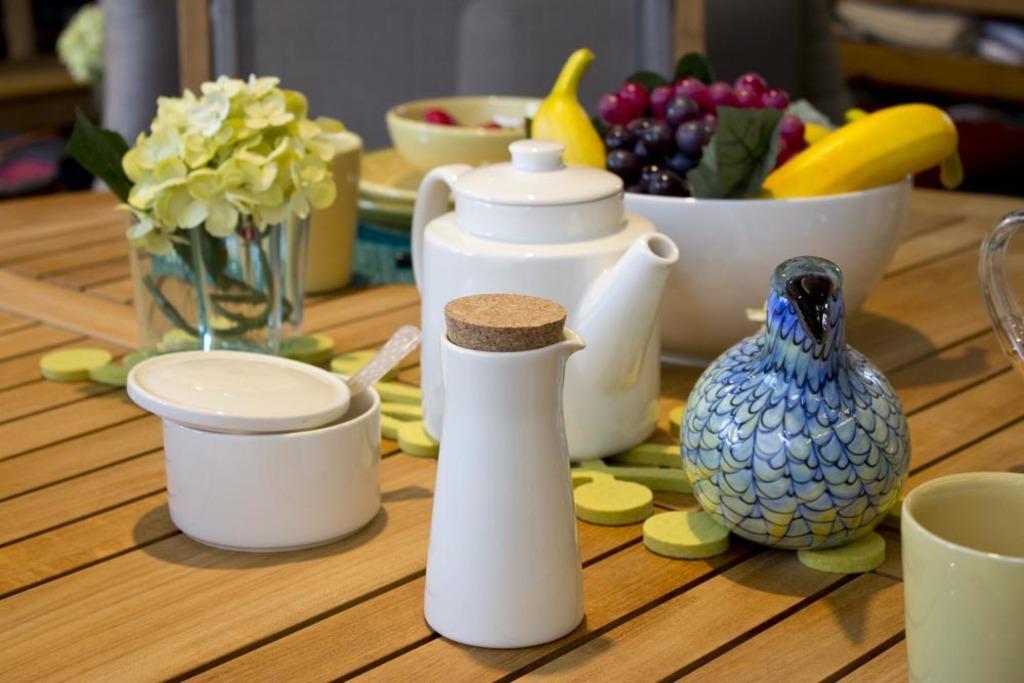In one or two sentences, can you explain what this image depicts? This is a cup,jar,tea pot and bowl full of fruits,flower vase on a table. 